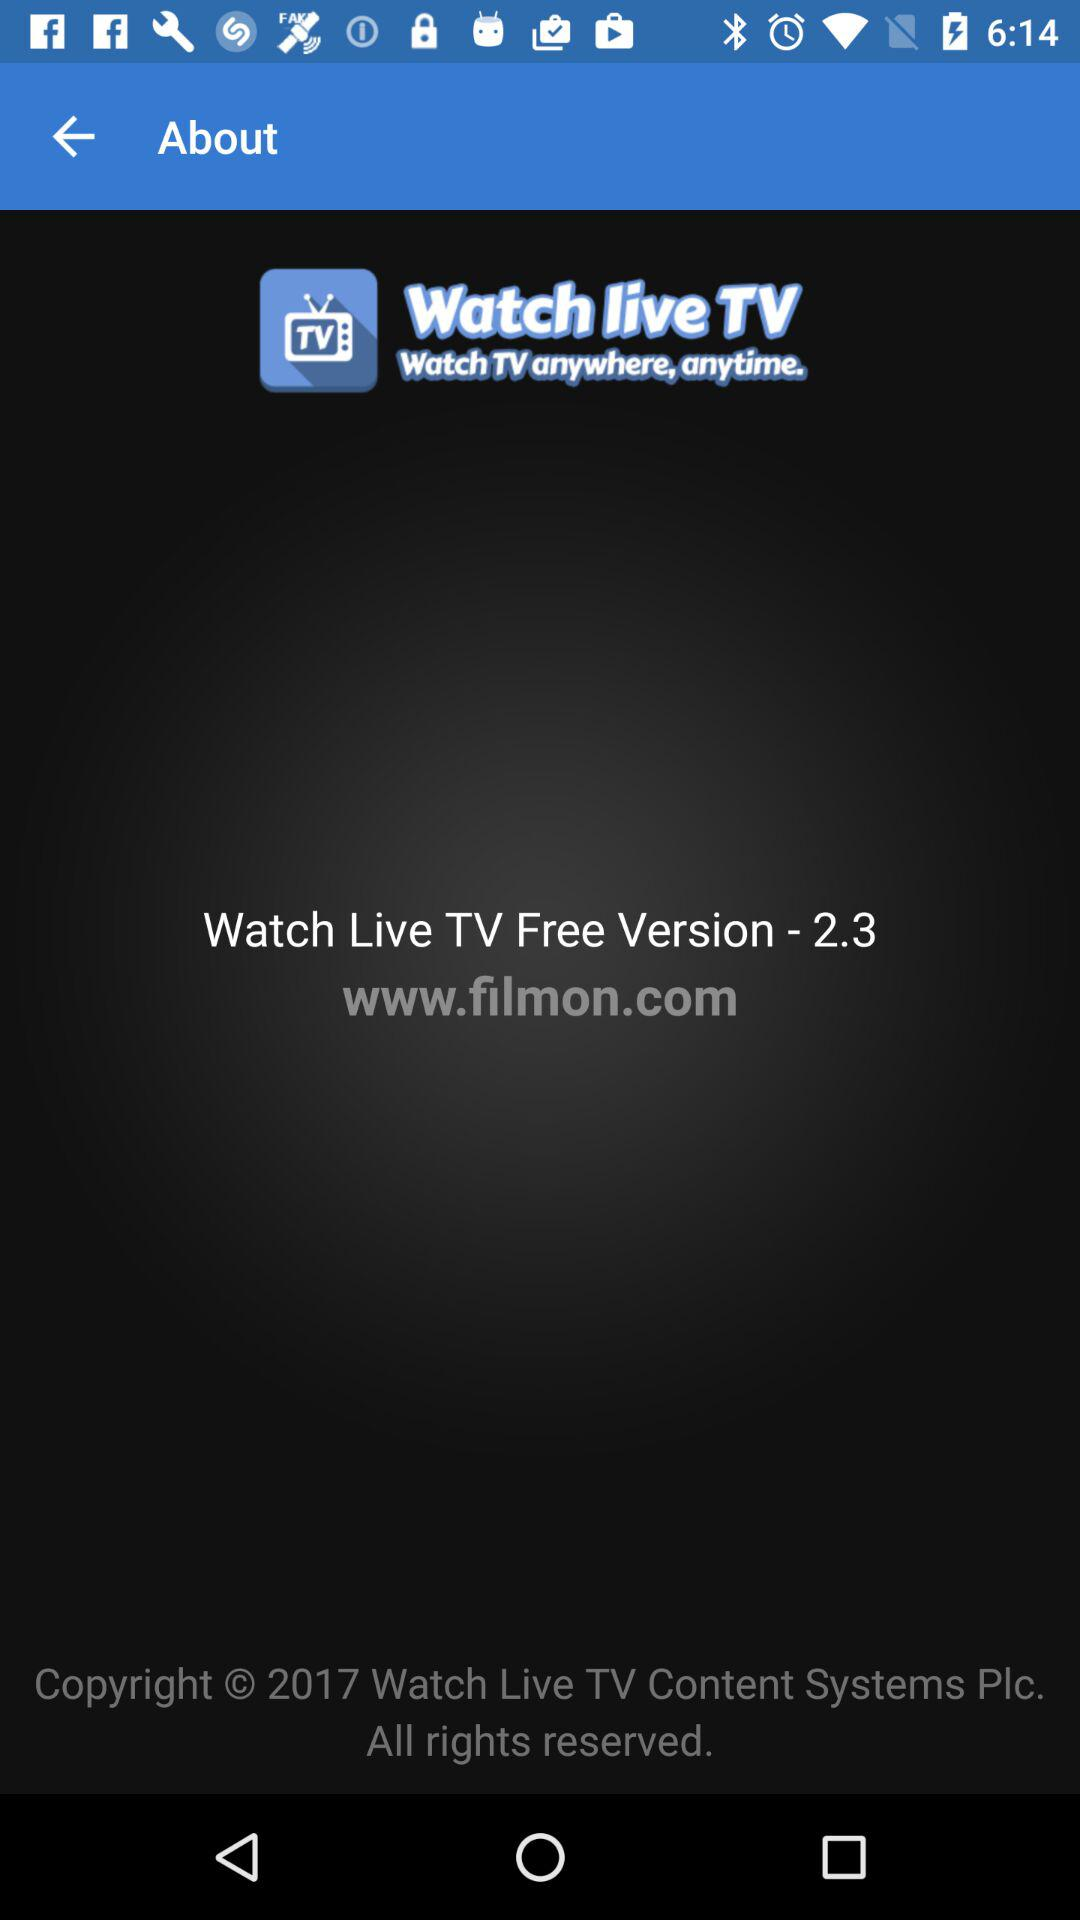What is the version? The version is 2.3. 